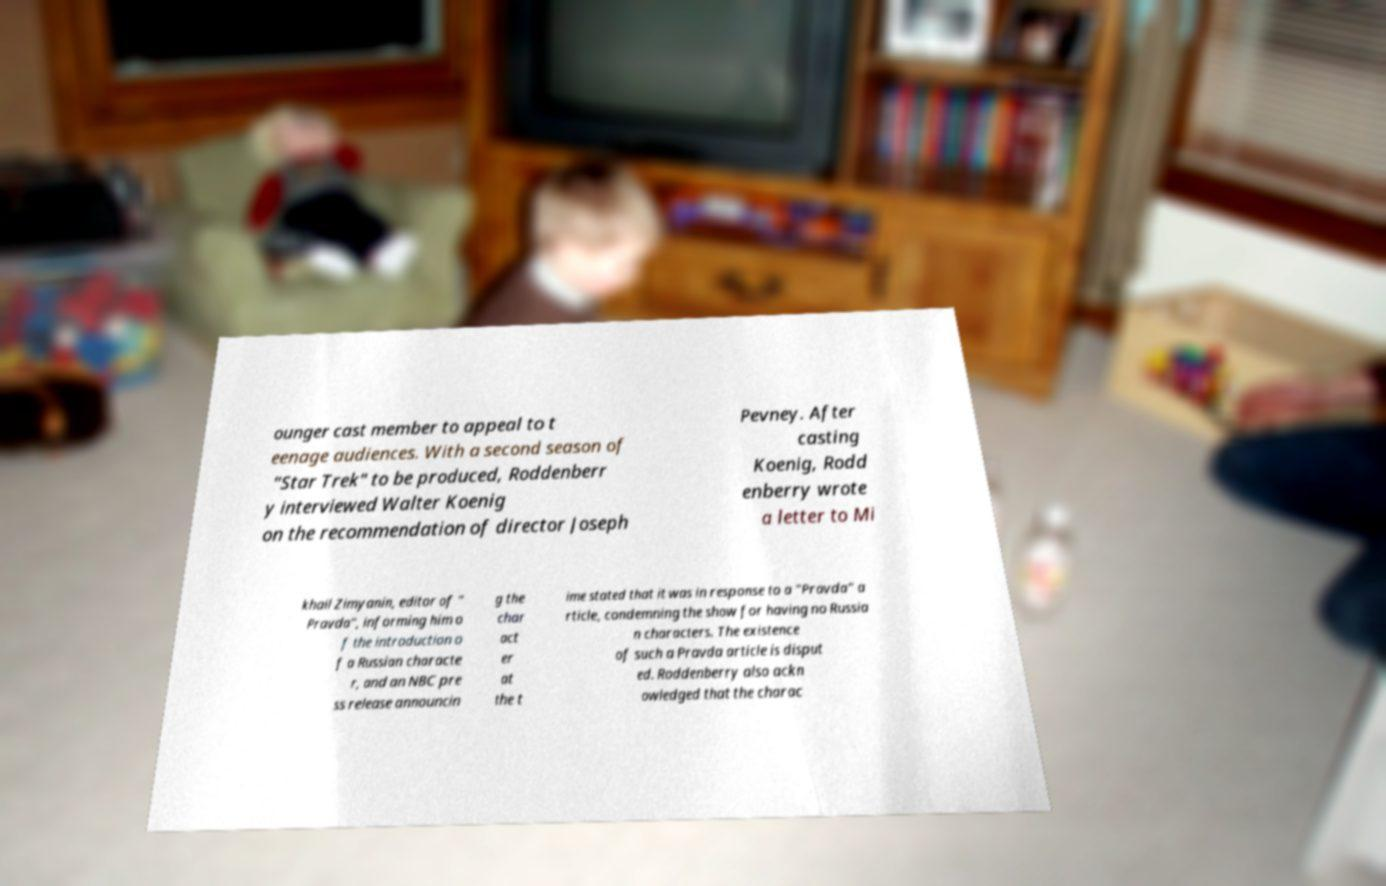I need the written content from this picture converted into text. Can you do that? ounger cast member to appeal to t eenage audiences. With a second season of "Star Trek" to be produced, Roddenberr y interviewed Walter Koenig on the recommendation of director Joseph Pevney. After casting Koenig, Rodd enberry wrote a letter to Mi khail Zimyanin, editor of " Pravda", informing him o f the introduction o f a Russian characte r, and an NBC pre ss release announcin g the char act er at the t ime stated that it was in response to a "Pravda" a rticle, condemning the show for having no Russia n characters. The existence of such a Pravda article is disput ed. Roddenberry also ackn owledged that the charac 